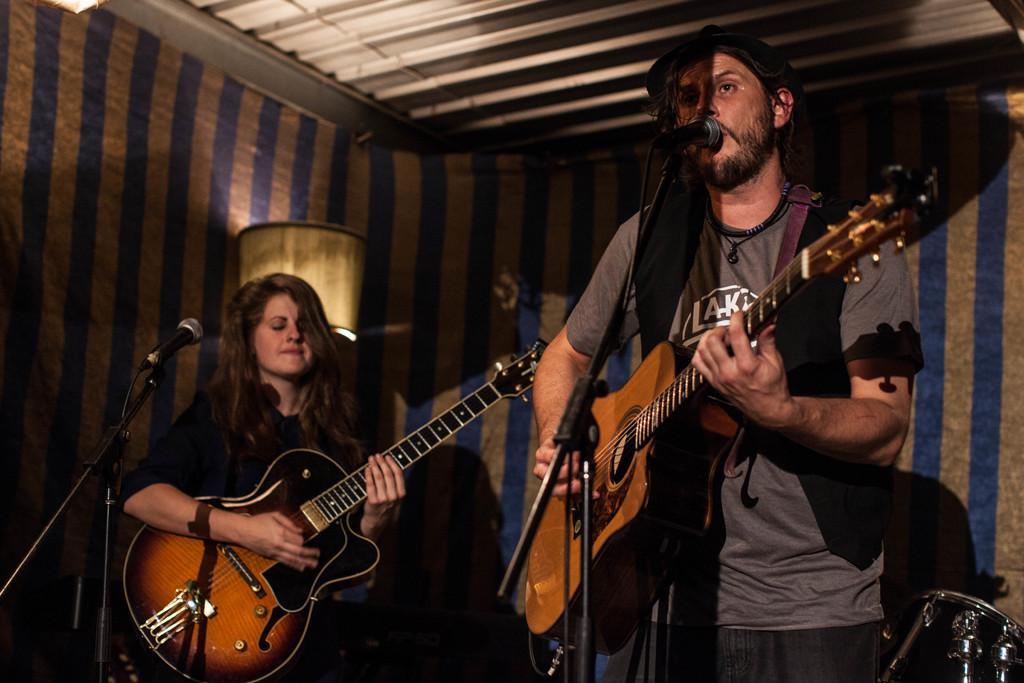How would you summarize this image in a sentence or two? In this picture we can see a women and a man who are standing in front of mike. They are playing guitar. On the background there is a wall. 